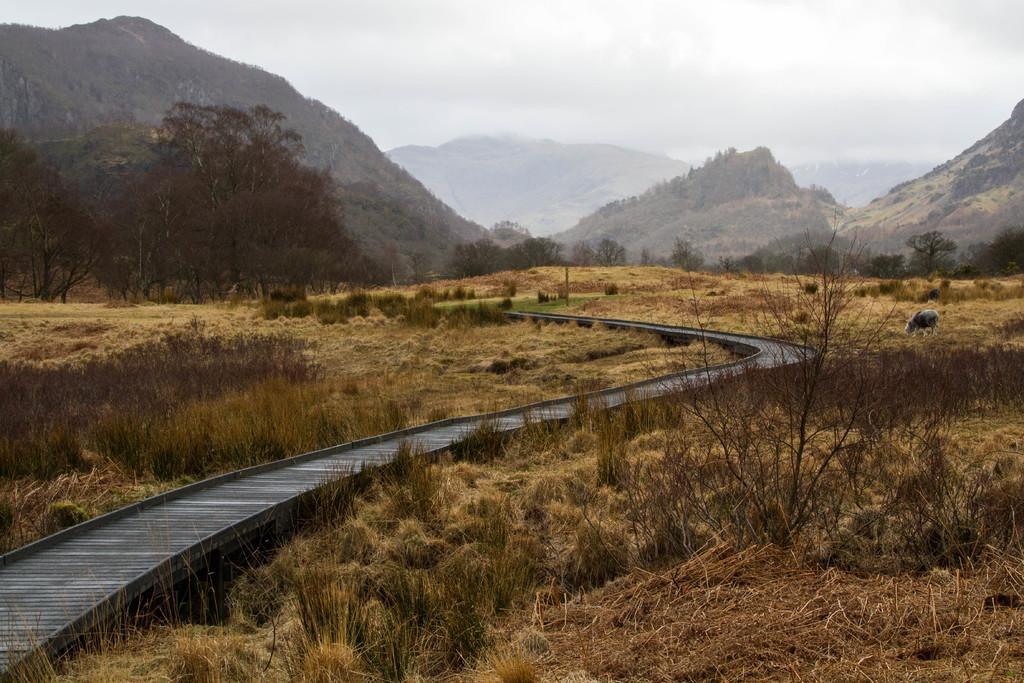How would you summarize this image in a sentence or two? In the center of the image there is a track. At the bottom of the image there is grass on the surface. On the right side of the image there is an animal. In the background of the image there are trees, mountains and sky. 